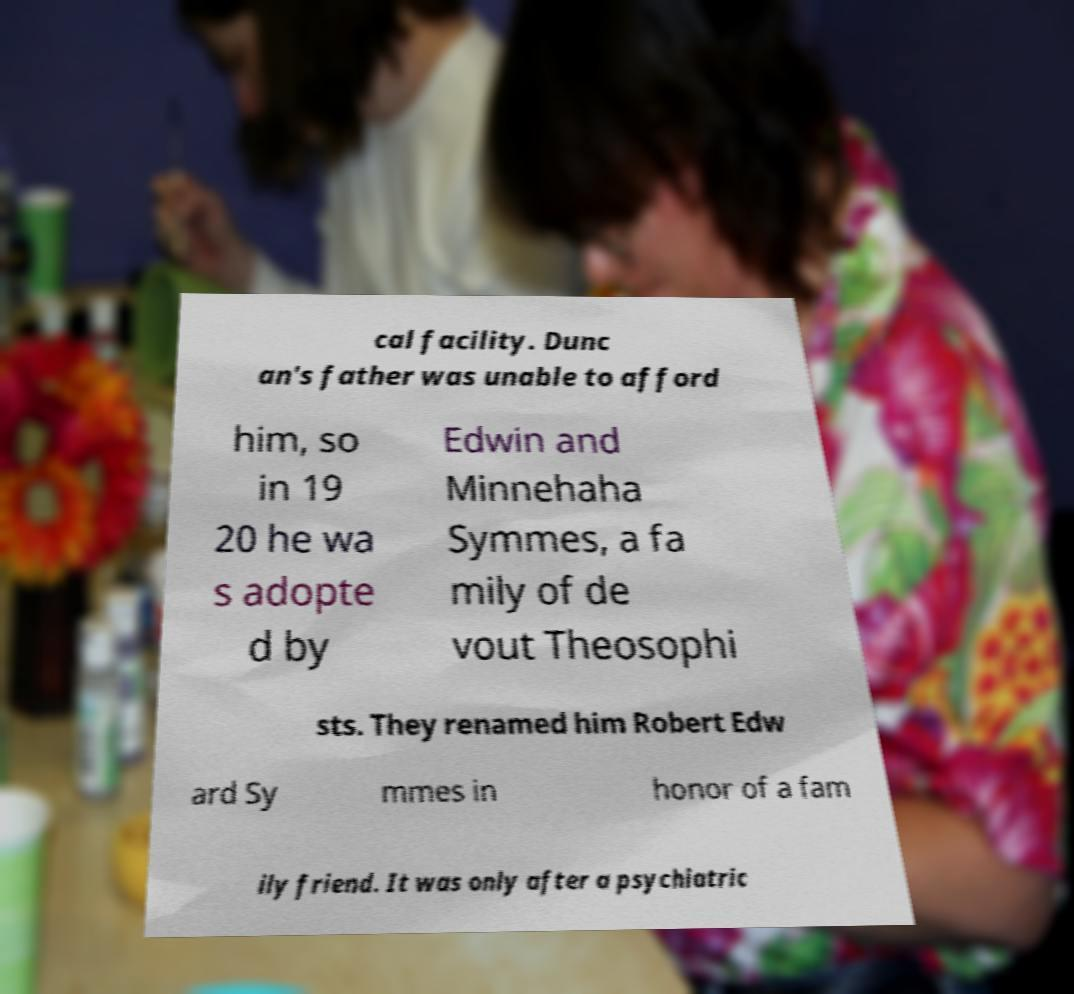There's text embedded in this image that I need extracted. Can you transcribe it verbatim? cal facility. Dunc an's father was unable to afford him, so in 19 20 he wa s adopte d by Edwin and Minnehaha Symmes, a fa mily of de vout Theosophi sts. They renamed him Robert Edw ard Sy mmes in honor of a fam ily friend. It was only after a psychiatric 